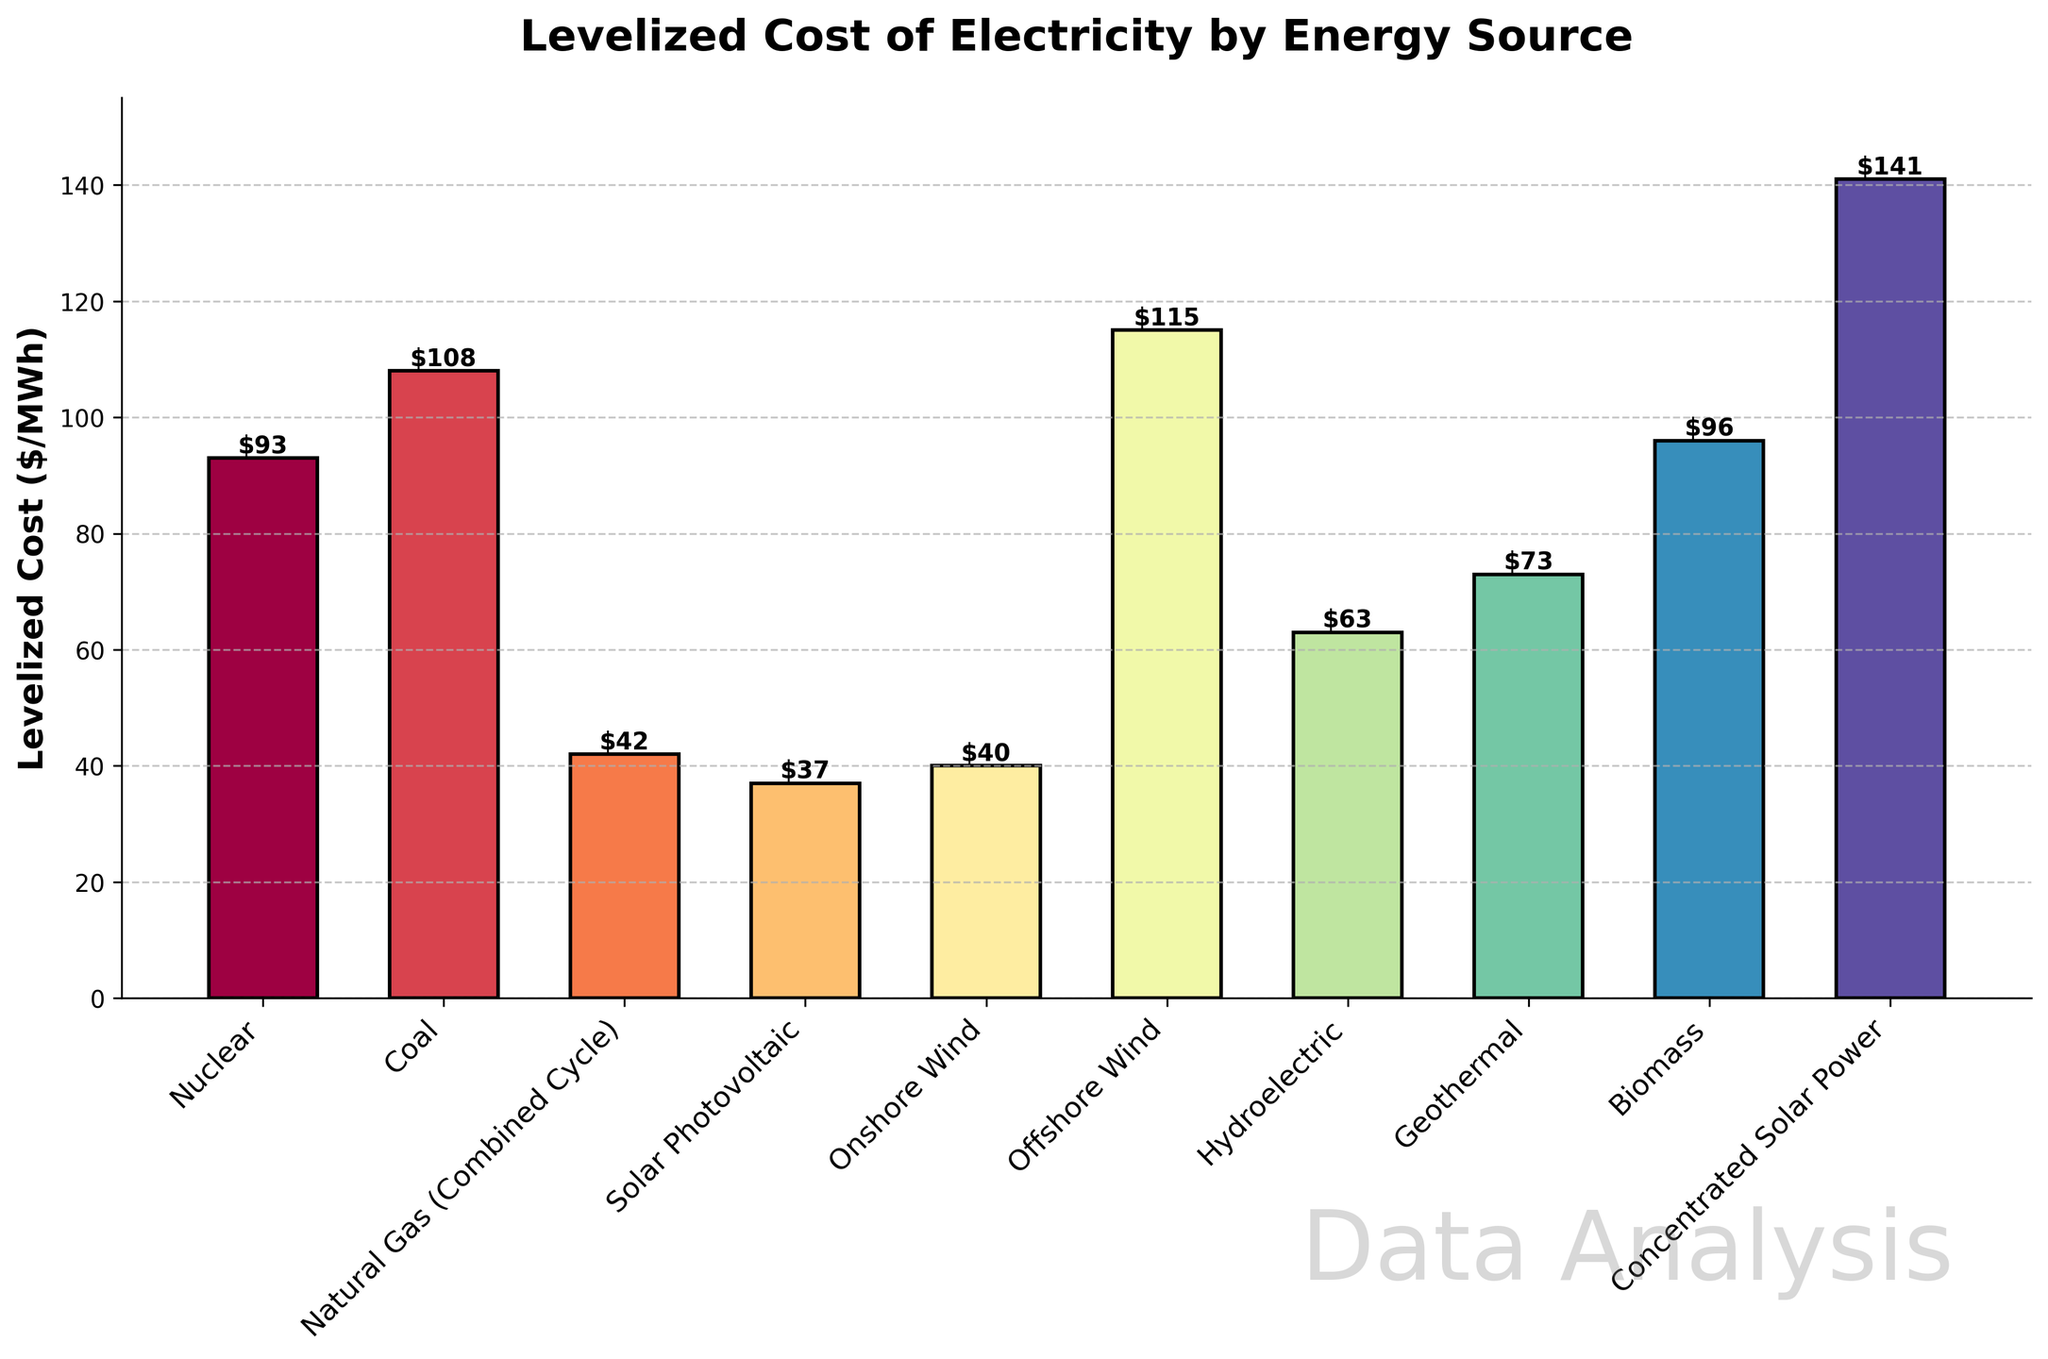Which energy source has the highest levelized cost of electricity? The bar corresponding to Concentrated Solar Power is the tallest, indicating it has the highest levelized cost of electricity.
Answer: Concentrated Solar Power What is the difference in levelized cost between Offshore Wind and Onshore Wind? Offshore Wind has a levelized cost of 115 $/MWh, and Onshore Wind has a cost of 40 $/MWh. The difference is 115 - 40 = 75 $/MWh.
Answer: 75 $/MWh Which energy sources have a levelized cost of electricity less than 50 $/MWh? The energy sources with bars shorter than the 50 $/MWh mark are Solar Photovoltaic (37 $/MWh), Natural Gas (Combined Cycle) (42 $/MWh), and Onshore Wind (40 $/MWh).
Answer: Solar Photovoltaic, Natural Gas (Combined Cycle), Onshore Wind What is the average levelized cost of electricity for Nuclear, Coal, and Biomass? Sum the costs of Nuclear (93 $/MWh), Coal (108 $/MWh), and Biomass (96 $/MWh), which is 93 + 108 + 96 = 297. Then divide by the number of energy sources (3), resulting in 297 / 3 = 99 $/MWh.
Answer: 99 $/MWh How does the levelized cost of Natural Gas compare to the average levelized cost of Solar Photovoltaic and Onshore Wind? The average of Solar Photovoltaic (37 $/MWh) and Onshore Wind (40 $/MWh) is (37 + 40) / 2 = 38.5 $/MWh. Comparing with Natural Gas (42 $/MWh), 42 > 38.5.
Answer: Higher Which energy source is directly more cost-effective than Hydroelectric but more expensive than Solar Photovoltaic? Hydroelectric has a levelized cost of 63 $/MWh. The energy sources more cost-effective and more expensive than Solar Photovoltaic (37 $/MWh) are those between 37 $/MWh and 63 $/MWh, which is Natural Gas (Combined Cycle) at 42 $/MWh.
Answer: Natural Gas (Combined Cycle) What is the total levelized cost for all renewable energy sources represented (Solar Photovoltaic, Onshore Wind, Offshore Wind, Hydroelectric, Geothermal, Biomass, and Concentrated Solar Power)? Sum the costs for all renewable sources: 37 (Solar Photovoltaic) + 40 (Onshore Wind) + 115 (Offshore Wind) + 63 (Hydroelectric) + 73 (Geothermal) + 96 (Biomass) + 141 (Concentrated Solar Power) = 565 $/MWh.
Answer: 565 $/MWh 